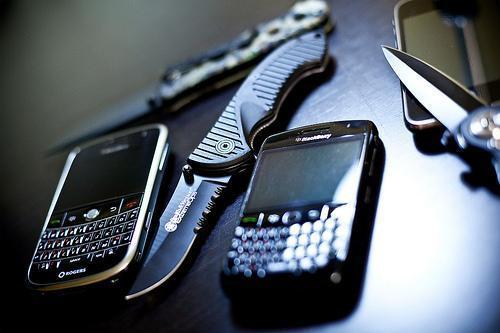How many phones are covered with a knife?
Give a very brief answer. 1. How many knives are pointing downward?
Give a very brief answer. 2. 